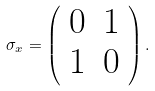Convert formula to latex. <formula><loc_0><loc_0><loc_500><loc_500>\sigma _ { x } = \left ( \begin{array} { l r } 0 & 1 \\ 1 & 0 \end{array} \right ) .</formula> 